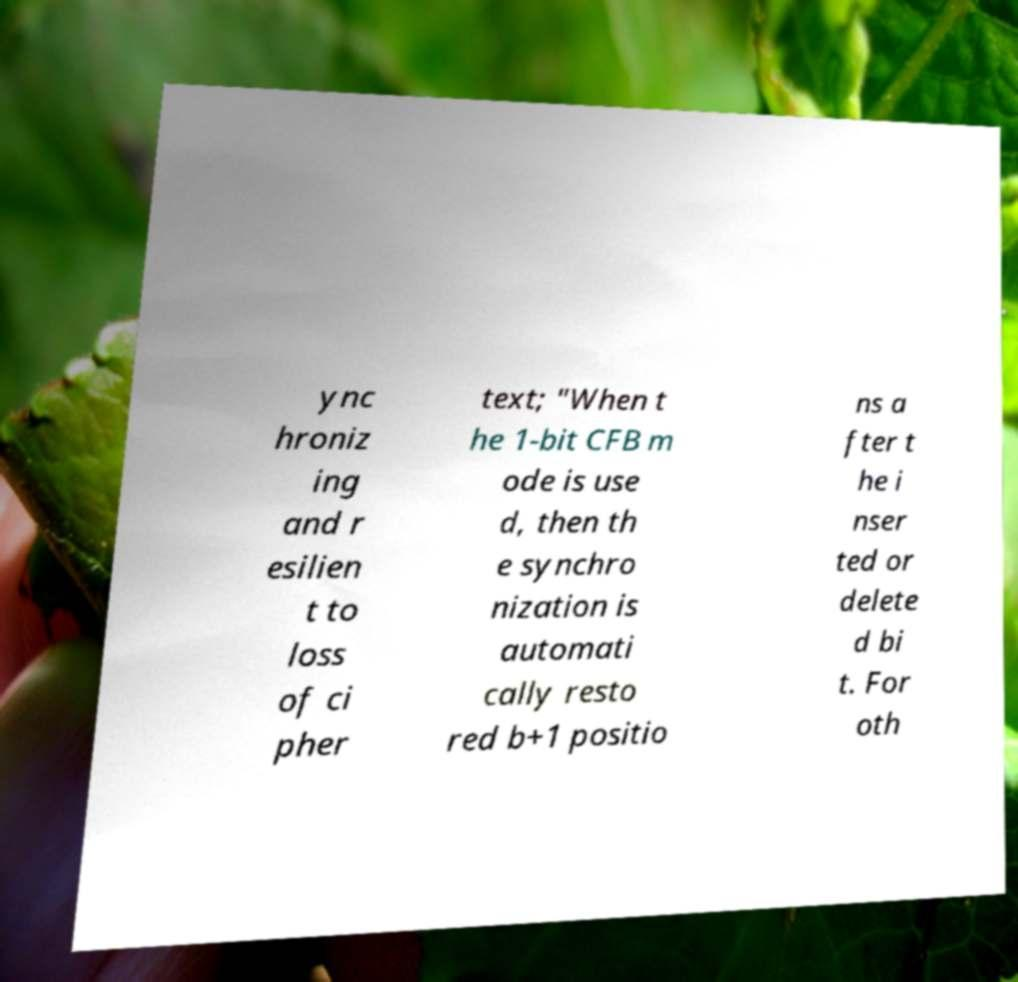What messages or text are displayed in this image? I need them in a readable, typed format. ync hroniz ing and r esilien t to loss of ci pher text; "When t he 1-bit CFB m ode is use d, then th e synchro nization is automati cally resto red b+1 positio ns a fter t he i nser ted or delete d bi t. For oth 